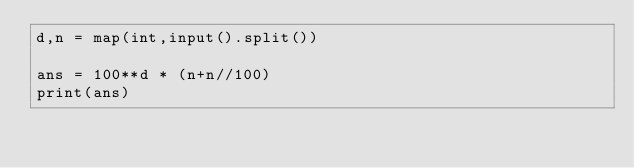Convert code to text. <code><loc_0><loc_0><loc_500><loc_500><_Python_>d,n = map(int,input().split())

ans = 100**d * (n+n//100)
print(ans)</code> 